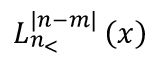Convert formula to latex. <formula><loc_0><loc_0><loc_500><loc_500>L _ { n _ { < } } ^ { | n - m | } \left ( x \right )</formula> 